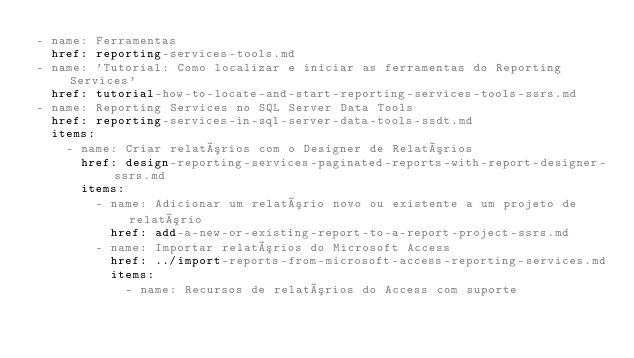<code> <loc_0><loc_0><loc_500><loc_500><_YAML_>- name: Ferramentas
  href: reporting-services-tools.md
- name: 'Tutorial: Como localizar e iniciar as ferramentas do Reporting Services'
  href: tutorial-how-to-locate-and-start-reporting-services-tools-ssrs.md
- name: Reporting Services no SQL Server Data Tools
  href: reporting-services-in-sql-server-data-tools-ssdt.md
  items:
    - name: Criar relatórios com o Designer de Relatórios
      href: design-reporting-services-paginated-reports-with-report-designer-ssrs.md
      items:
        - name: Adicionar um relatório novo ou existente a um projeto de relatório
          href: add-a-new-or-existing-report-to-a-report-project-ssrs.md
        - name: Importar relatórios do Microsoft Access
          href: ../import-reports-from-microsoft-access-reporting-services.md
          items:
            - name: Recursos de relatórios do Access com suporte</code> 